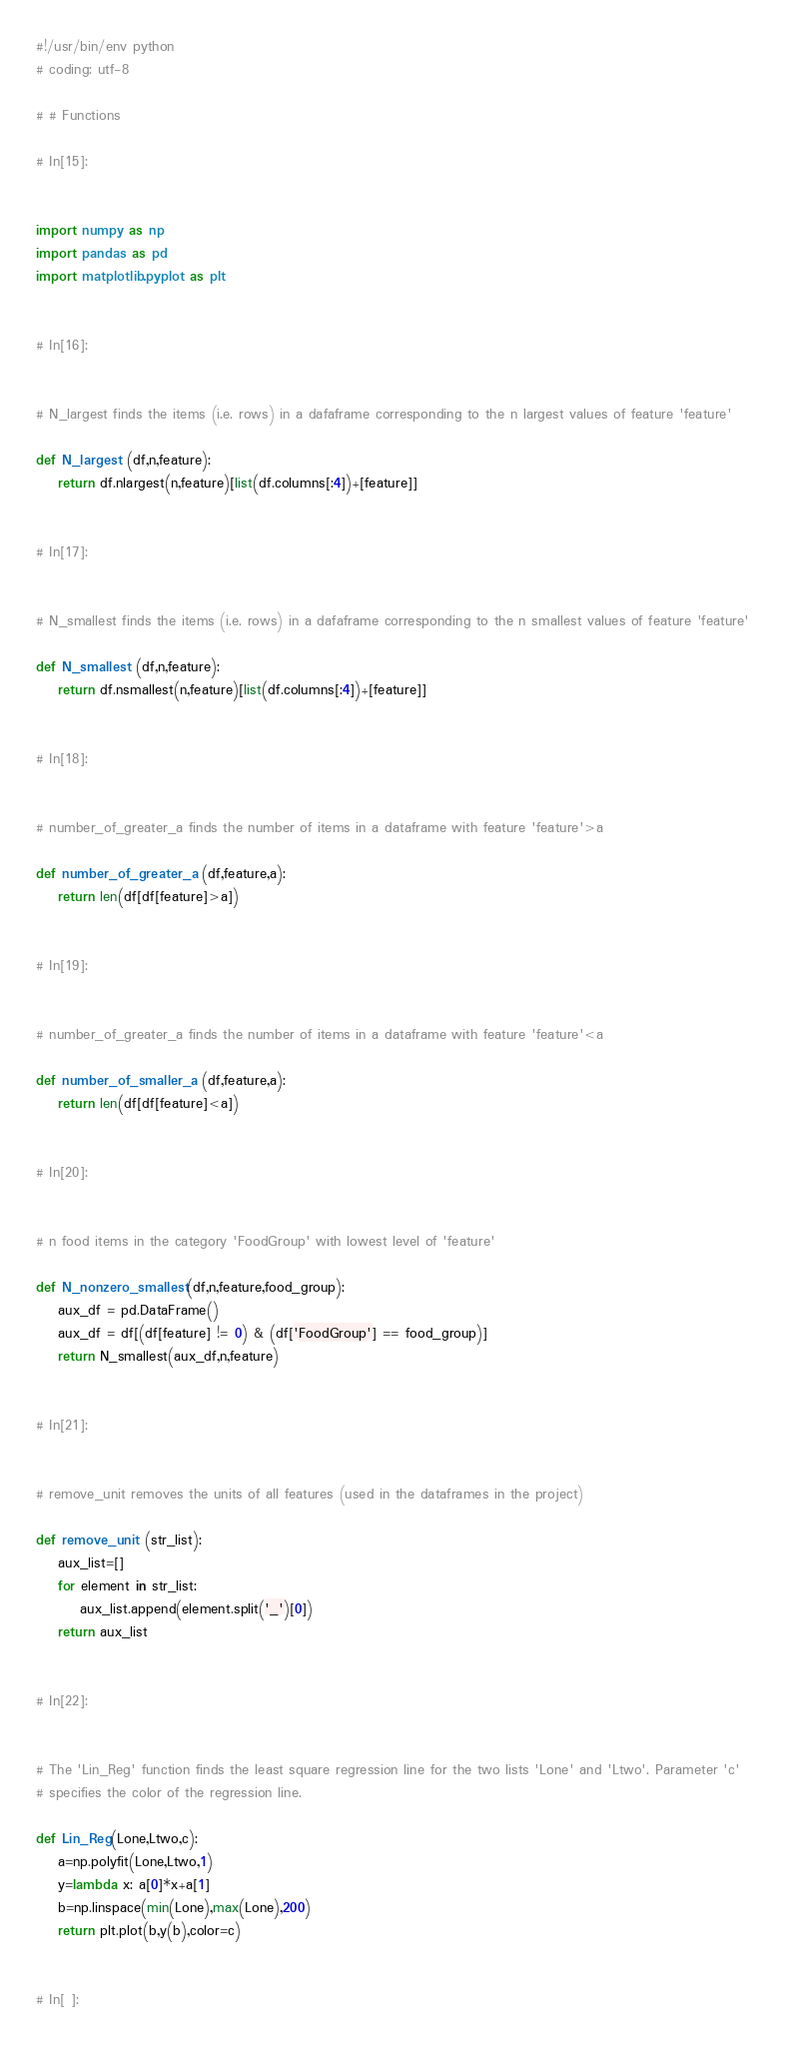<code> <loc_0><loc_0><loc_500><loc_500><_Python_>#!/usr/bin/env python
# coding: utf-8

# # Functions

# In[15]:


import numpy as np
import pandas as pd
import matplotlib.pyplot as plt


# In[16]:


# N_largest finds the items (i.e. rows) in a dafaframe corresponding to the n largest values of feature 'feature'

def N_largest (df,n,feature):
    return df.nlargest(n,feature)[list(df.columns[:4])+[feature]]


# In[17]:


# N_smallest finds the items (i.e. rows) in a dafaframe corresponding to the n smallest values of feature 'feature'

def N_smallest (df,n,feature):
    return df.nsmallest(n,feature)[list(df.columns[:4])+[feature]]


# In[18]:


# number_of_greater_a finds the number of items in a dataframe with feature 'feature'>a

def number_of_greater_a (df,feature,a):
    return len(df[df[feature]>a])


# In[19]:


# number_of_greater_a finds the number of items in a dataframe with feature 'feature'<a

def number_of_smaller_a (df,feature,a):
    return len(df[df[feature]<a])


# In[20]:


# n food items in the category 'FoodGroup' with lowest level of 'feature'

def N_nonzero_smallest(df,n,feature,food_group):
    aux_df = pd.DataFrame()
    aux_df = df[(df[feature] != 0) & (df['FoodGroup'] == food_group)]
    return N_smallest(aux_df,n,feature)


# In[21]:


# remove_unit removes the units of all features (used in the dataframes in the project)

def remove_unit (str_list):
    aux_list=[]
    for element in str_list:
        aux_list.append(element.split('_')[0])
    return aux_list


# In[22]:


# The 'Lin_Reg' function finds the least square regression line for the two lists 'Lone' and 'Ltwo'. Parameter 'c'
# specifies the color of the regression line.

def Lin_Reg(Lone,Ltwo,c):
    a=np.polyfit(Lone,Ltwo,1)
    y=lambda x: a[0]*x+a[1]
    b=np.linspace(min(Lone),max(Lone),200)
    return plt.plot(b,y(b),color=c)


# In[ ]:




</code> 